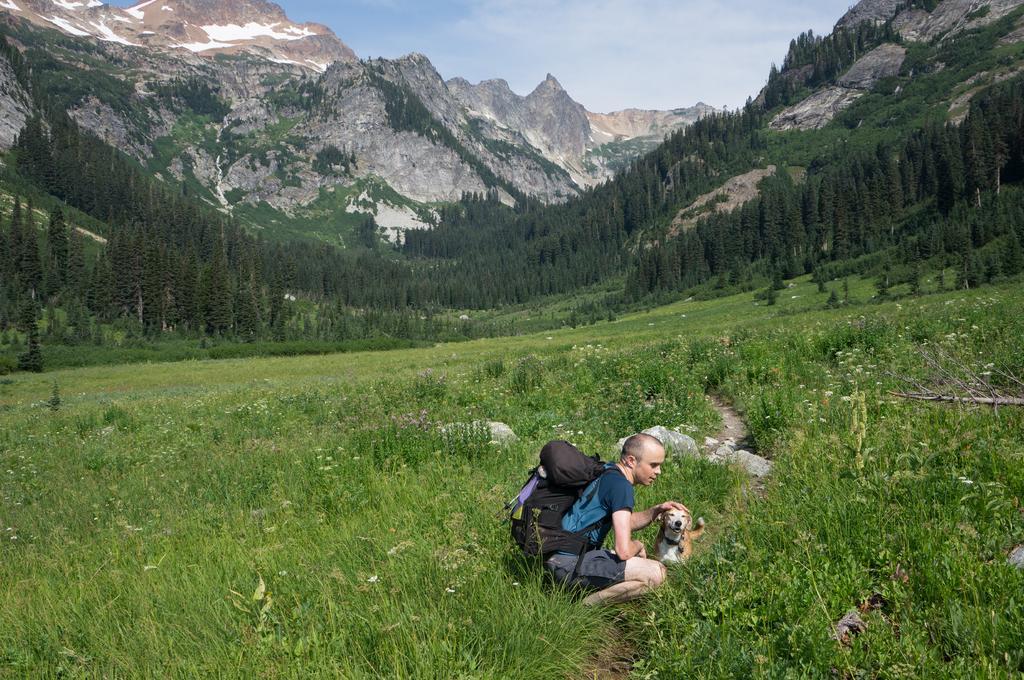How would you summarize this image in a sentence or two? In this picture we can see a person in the ground. He is carrying his backpack. There is a dog. And this is the grass. On the background we can see a mountain. These are the trees and there is a sky. 